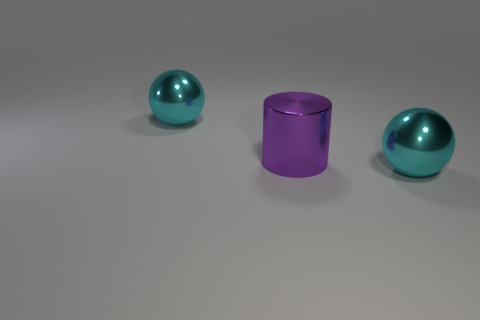Add 1 tiny blue matte things. How many objects exist? 4 Subtract all cylinders. How many objects are left? 2 Add 1 cyan metal objects. How many cyan metal objects are left? 3 Add 3 cyan metal balls. How many cyan metal balls exist? 5 Subtract 0 gray spheres. How many objects are left? 3 Subtract all big objects. Subtract all small matte spheres. How many objects are left? 0 